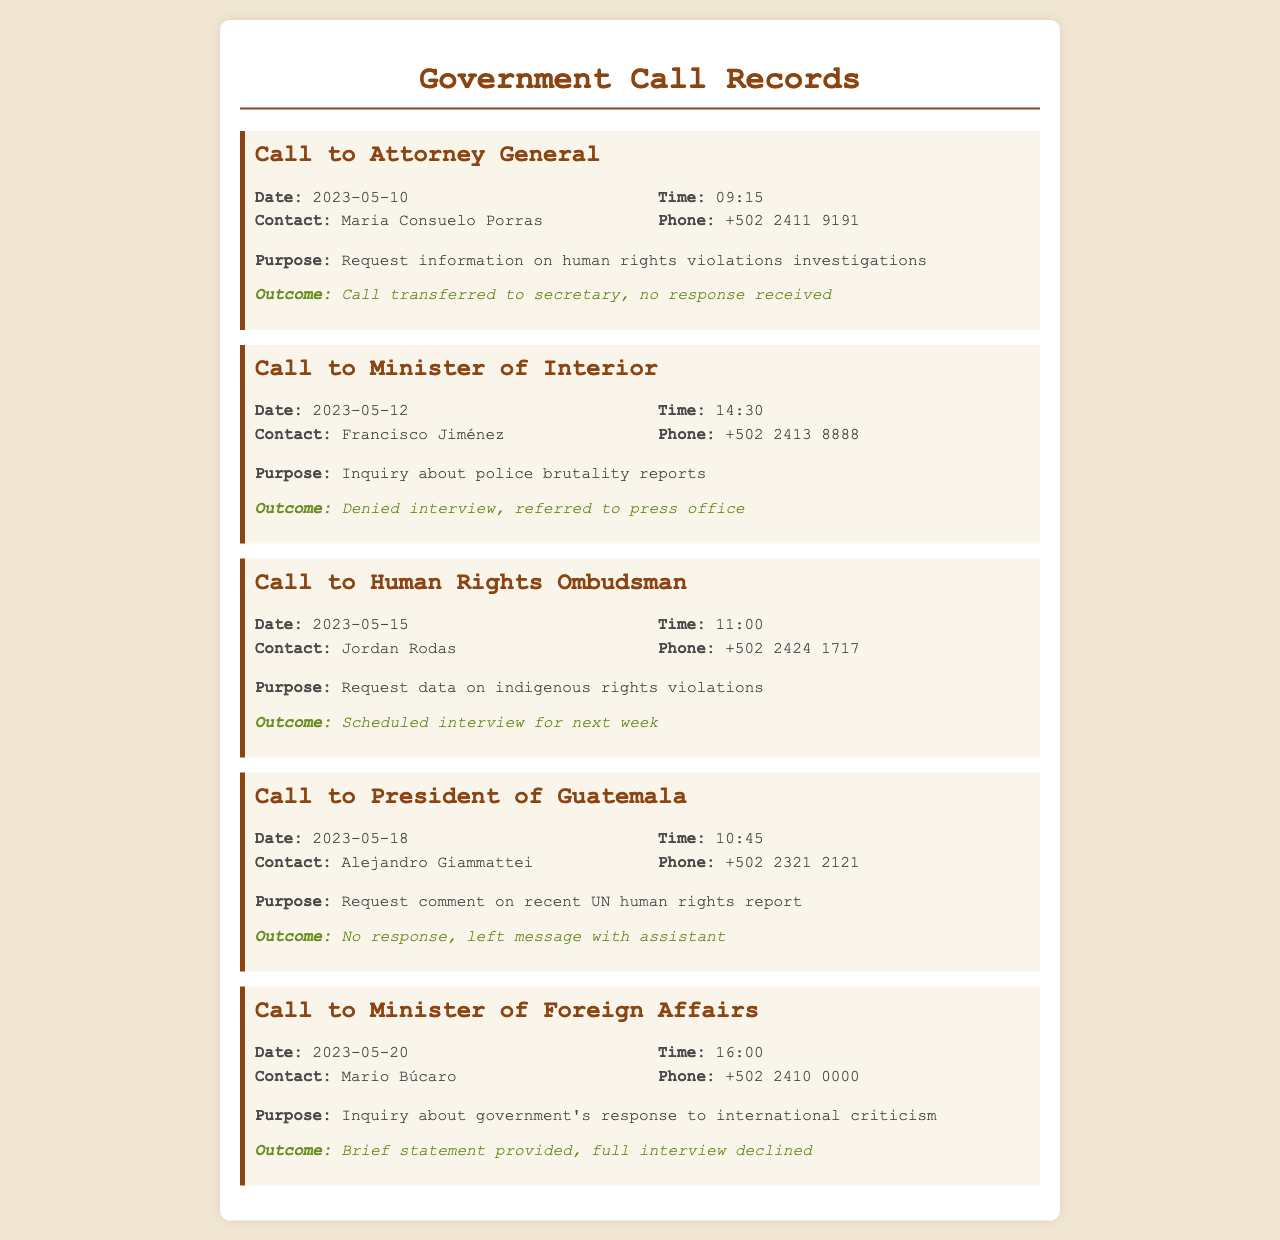What is the date of the call to the Attorney General? The call to the Attorney General occurred on 2023-05-10, as indicated in the document.
Answer: 2023-05-10 Who is the contact for the call made on May 12? The contact for the call made on May 12 is Francisco Jiménez, as listed in the document.
Answer: Francisco Jiménez What was the outcome of the call to the President of Guatemala? The outcome of the call was that there was no response, and a message was left with the assistant.
Answer: No response, left message with assistant Which official was referred to the press office? The Minister of Interior's assistant denied the interview and referred the request to the press office.
Answer: Minister of Interior What is the purpose of the call to the Human Rights Ombudsman? The purpose was to request data on indigenous rights violations, as specified in the document.
Answer: Request data on indigenous rights violations What was the scheduled outcome from the call to the Human Rights Ombudsman? An interview was scheduled for the next week following the call to the Human Rights Ombudsman.
Answer: Scheduled interview for next week What is the phone number for the Minister of Foreign Affairs? The phone number for the Minister of Foreign Affairs is +502 2410 0000, as provided in the document.
Answer: +502 2410 0000 Which official’s call was made to inquire about police brutality reports? The call made to inquire about police brutality reports was directed to the Minister of Interior.
Answer: Minister of Interior 